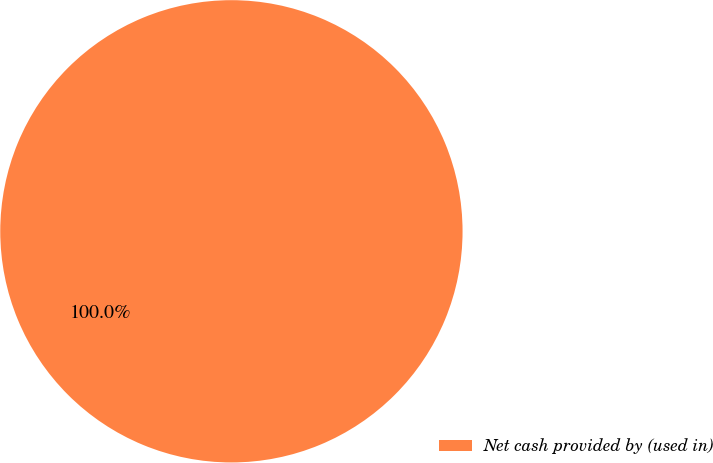Convert chart. <chart><loc_0><loc_0><loc_500><loc_500><pie_chart><fcel>Net cash provided by (used in)<nl><fcel>100.0%<nl></chart> 